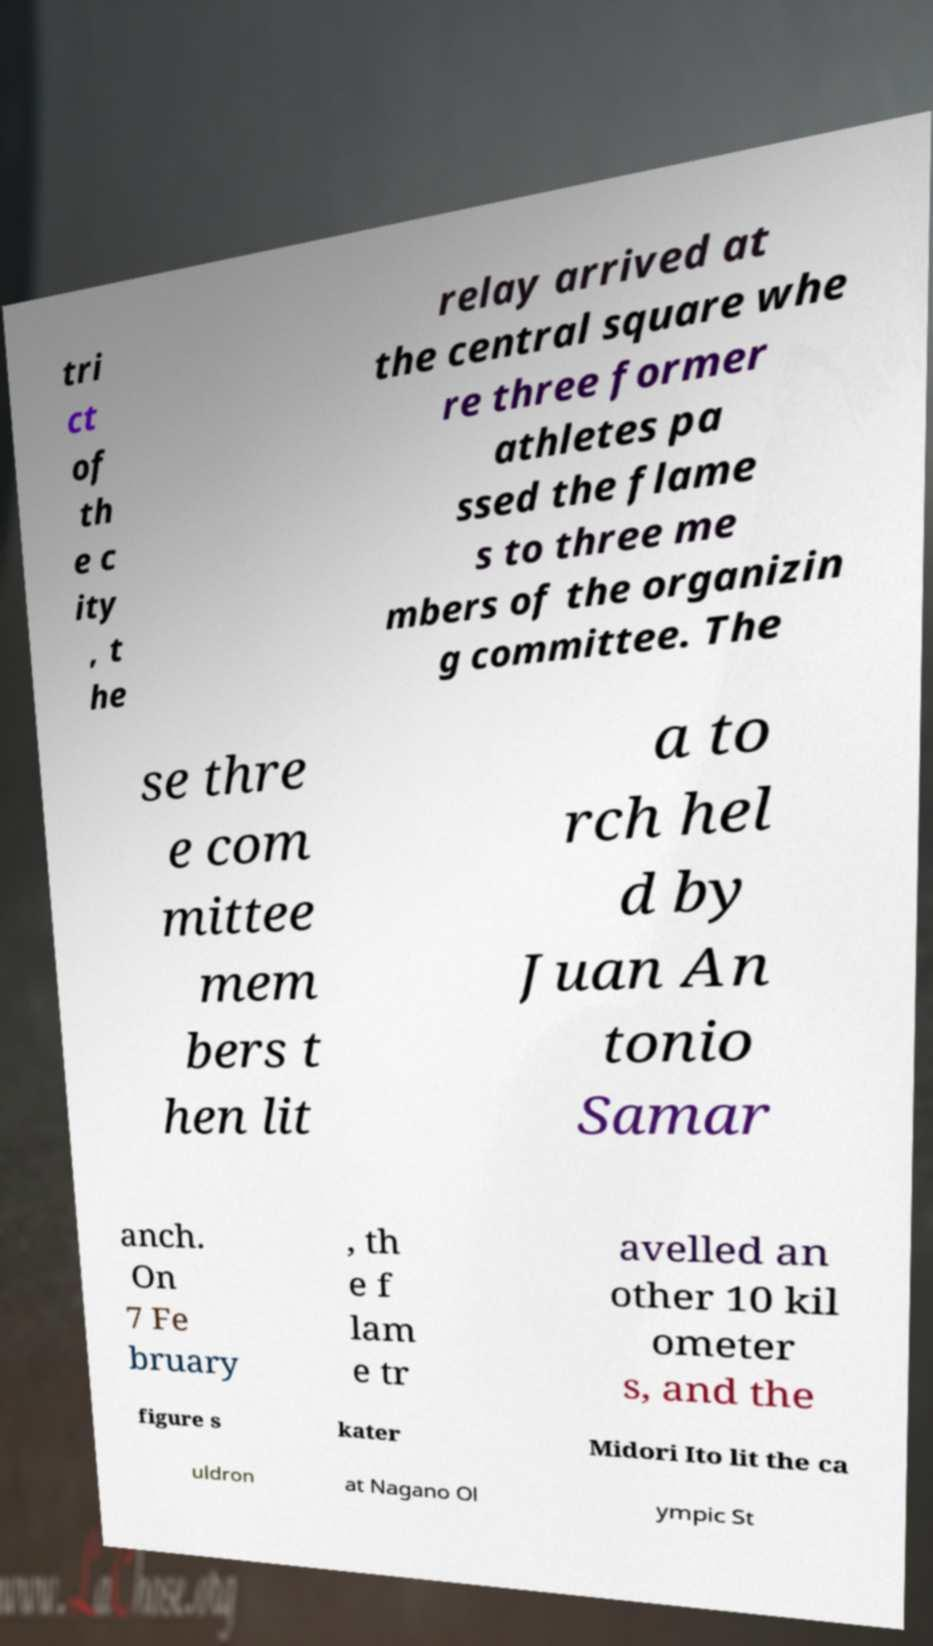I need the written content from this picture converted into text. Can you do that? tri ct of th e c ity , t he relay arrived at the central square whe re three former athletes pa ssed the flame s to three me mbers of the organizin g committee. The se thre e com mittee mem bers t hen lit a to rch hel d by Juan An tonio Samar anch. On 7 Fe bruary , th e f lam e tr avelled an other 10 kil ometer s, and the figure s kater Midori Ito lit the ca uldron at Nagano Ol ympic St 